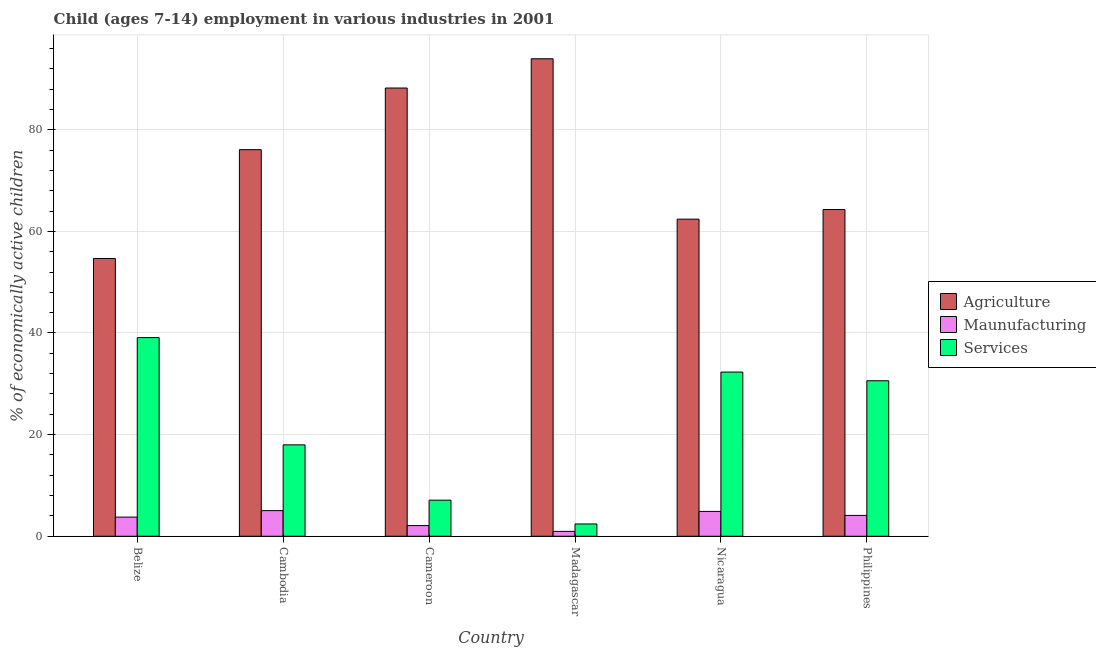How many groups of bars are there?
Provide a succinct answer. 6. Are the number of bars on each tick of the X-axis equal?
Provide a succinct answer. Yes. What is the label of the 5th group of bars from the left?
Offer a very short reply. Nicaragua. In how many cases, is the number of bars for a given country not equal to the number of legend labels?
Your response must be concise. 0. Across all countries, what is the maximum percentage of economically active children in manufacturing?
Your answer should be compact. 5.04. Across all countries, what is the minimum percentage of economically active children in manufacturing?
Make the answer very short. 0.96. In which country was the percentage of economically active children in agriculture maximum?
Provide a succinct answer. Madagascar. In which country was the percentage of economically active children in manufacturing minimum?
Your response must be concise. Madagascar. What is the total percentage of economically active children in agriculture in the graph?
Your answer should be compact. 439.63. What is the difference between the percentage of economically active children in services in Belize and that in Philippines?
Your response must be concise. 8.49. What is the difference between the percentage of economically active children in manufacturing in Cambodia and the percentage of economically active children in agriculture in Madagascar?
Ensure brevity in your answer.  -88.93. What is the average percentage of economically active children in agriculture per country?
Keep it short and to the point. 73.27. What is the difference between the percentage of economically active children in agriculture and percentage of economically active children in manufacturing in Madagascar?
Offer a terse response. 93.01. What is the ratio of the percentage of economically active children in manufacturing in Madagascar to that in Nicaragua?
Keep it short and to the point. 0.2. Is the difference between the percentage of economically active children in agriculture in Cambodia and Nicaragua greater than the difference between the percentage of economically active children in manufacturing in Cambodia and Nicaragua?
Offer a very short reply. Yes. What is the difference between the highest and the second highest percentage of economically active children in services?
Offer a terse response. 6.78. What is the difference between the highest and the lowest percentage of economically active children in manufacturing?
Give a very brief answer. 4.08. What does the 1st bar from the left in Nicaragua represents?
Ensure brevity in your answer.  Agriculture. What does the 2nd bar from the right in Madagascar represents?
Provide a succinct answer. Maunufacturing. Is it the case that in every country, the sum of the percentage of economically active children in agriculture and percentage of economically active children in manufacturing is greater than the percentage of economically active children in services?
Offer a terse response. Yes. Are all the bars in the graph horizontal?
Ensure brevity in your answer.  No. Are the values on the major ticks of Y-axis written in scientific E-notation?
Offer a very short reply. No. Does the graph contain any zero values?
Your answer should be compact. No. Where does the legend appear in the graph?
Your answer should be very brief. Center right. How many legend labels are there?
Offer a terse response. 3. What is the title of the graph?
Your answer should be very brief. Child (ages 7-14) employment in various industries in 2001. What is the label or title of the X-axis?
Make the answer very short. Country. What is the label or title of the Y-axis?
Keep it short and to the point. % of economically active children. What is the % of economically active children in Agriculture in Belize?
Offer a terse response. 54.66. What is the % of economically active children of Maunufacturing in Belize?
Your answer should be compact. 3.77. What is the % of economically active children of Services in Belize?
Offer a terse response. 39.09. What is the % of economically active children of Agriculture in Cambodia?
Make the answer very short. 76.08. What is the % of economically active children in Maunufacturing in Cambodia?
Ensure brevity in your answer.  5.04. What is the % of economically active children in Services in Cambodia?
Your response must be concise. 17.99. What is the % of economically active children in Agriculture in Cameroon?
Provide a succinct answer. 88.21. What is the % of economically active children of Maunufacturing in Cameroon?
Your answer should be very brief. 2.1. What is the % of economically active children of Services in Cameroon?
Provide a short and direct response. 7.1. What is the % of economically active children in Agriculture in Madagascar?
Offer a terse response. 93.97. What is the % of economically active children of Services in Madagascar?
Provide a short and direct response. 2.42. What is the % of economically active children in Agriculture in Nicaragua?
Keep it short and to the point. 62.41. What is the % of economically active children of Maunufacturing in Nicaragua?
Your response must be concise. 4.89. What is the % of economically active children in Services in Nicaragua?
Provide a succinct answer. 32.31. What is the % of economically active children of Agriculture in Philippines?
Your answer should be very brief. 64.3. What is the % of economically active children of Maunufacturing in Philippines?
Give a very brief answer. 4.1. What is the % of economically active children of Services in Philippines?
Ensure brevity in your answer.  30.6. Across all countries, what is the maximum % of economically active children in Agriculture?
Provide a short and direct response. 93.97. Across all countries, what is the maximum % of economically active children of Maunufacturing?
Make the answer very short. 5.04. Across all countries, what is the maximum % of economically active children in Services?
Your answer should be very brief. 39.09. Across all countries, what is the minimum % of economically active children of Agriculture?
Your answer should be very brief. 54.66. Across all countries, what is the minimum % of economically active children in Maunufacturing?
Provide a short and direct response. 0.96. Across all countries, what is the minimum % of economically active children of Services?
Your answer should be compact. 2.42. What is the total % of economically active children in Agriculture in the graph?
Keep it short and to the point. 439.63. What is the total % of economically active children of Maunufacturing in the graph?
Offer a terse response. 20.86. What is the total % of economically active children in Services in the graph?
Offer a very short reply. 129.52. What is the difference between the % of economically active children in Agriculture in Belize and that in Cambodia?
Offer a terse response. -21.42. What is the difference between the % of economically active children in Maunufacturing in Belize and that in Cambodia?
Make the answer very short. -1.27. What is the difference between the % of economically active children of Services in Belize and that in Cambodia?
Your response must be concise. 21.1. What is the difference between the % of economically active children of Agriculture in Belize and that in Cameroon?
Your response must be concise. -33.55. What is the difference between the % of economically active children of Maunufacturing in Belize and that in Cameroon?
Your answer should be compact. 1.67. What is the difference between the % of economically active children in Services in Belize and that in Cameroon?
Ensure brevity in your answer.  31.99. What is the difference between the % of economically active children of Agriculture in Belize and that in Madagascar?
Your answer should be compact. -39.31. What is the difference between the % of economically active children in Maunufacturing in Belize and that in Madagascar?
Provide a short and direct response. 2.81. What is the difference between the % of economically active children of Services in Belize and that in Madagascar?
Offer a terse response. 36.67. What is the difference between the % of economically active children of Agriculture in Belize and that in Nicaragua?
Offer a very short reply. -7.74. What is the difference between the % of economically active children of Maunufacturing in Belize and that in Nicaragua?
Keep it short and to the point. -1.12. What is the difference between the % of economically active children of Services in Belize and that in Nicaragua?
Provide a short and direct response. 6.78. What is the difference between the % of economically active children of Agriculture in Belize and that in Philippines?
Provide a succinct answer. -9.64. What is the difference between the % of economically active children in Maunufacturing in Belize and that in Philippines?
Offer a terse response. -0.33. What is the difference between the % of economically active children in Services in Belize and that in Philippines?
Provide a short and direct response. 8.49. What is the difference between the % of economically active children in Agriculture in Cambodia and that in Cameroon?
Make the answer very short. -12.13. What is the difference between the % of economically active children of Maunufacturing in Cambodia and that in Cameroon?
Your answer should be very brief. 2.94. What is the difference between the % of economically active children in Services in Cambodia and that in Cameroon?
Make the answer very short. 10.89. What is the difference between the % of economically active children of Agriculture in Cambodia and that in Madagascar?
Provide a succinct answer. -17.89. What is the difference between the % of economically active children in Maunufacturing in Cambodia and that in Madagascar?
Ensure brevity in your answer.  4.08. What is the difference between the % of economically active children in Services in Cambodia and that in Madagascar?
Provide a succinct answer. 15.57. What is the difference between the % of economically active children in Agriculture in Cambodia and that in Nicaragua?
Offer a very short reply. 13.67. What is the difference between the % of economically active children of Maunufacturing in Cambodia and that in Nicaragua?
Your answer should be compact. 0.15. What is the difference between the % of economically active children of Services in Cambodia and that in Nicaragua?
Your answer should be very brief. -14.32. What is the difference between the % of economically active children of Agriculture in Cambodia and that in Philippines?
Your answer should be very brief. 11.78. What is the difference between the % of economically active children of Maunufacturing in Cambodia and that in Philippines?
Your answer should be very brief. 0.94. What is the difference between the % of economically active children of Services in Cambodia and that in Philippines?
Ensure brevity in your answer.  -12.61. What is the difference between the % of economically active children in Agriculture in Cameroon and that in Madagascar?
Provide a succinct answer. -5.76. What is the difference between the % of economically active children in Maunufacturing in Cameroon and that in Madagascar?
Provide a short and direct response. 1.14. What is the difference between the % of economically active children in Services in Cameroon and that in Madagascar?
Provide a succinct answer. 4.68. What is the difference between the % of economically active children in Agriculture in Cameroon and that in Nicaragua?
Ensure brevity in your answer.  25.8. What is the difference between the % of economically active children in Maunufacturing in Cameroon and that in Nicaragua?
Your response must be concise. -2.79. What is the difference between the % of economically active children in Services in Cameroon and that in Nicaragua?
Provide a succinct answer. -25.21. What is the difference between the % of economically active children in Agriculture in Cameroon and that in Philippines?
Provide a short and direct response. 23.91. What is the difference between the % of economically active children in Services in Cameroon and that in Philippines?
Provide a short and direct response. -23.5. What is the difference between the % of economically active children of Agriculture in Madagascar and that in Nicaragua?
Give a very brief answer. 31.56. What is the difference between the % of economically active children of Maunufacturing in Madagascar and that in Nicaragua?
Make the answer very short. -3.93. What is the difference between the % of economically active children of Services in Madagascar and that in Nicaragua?
Make the answer very short. -29.89. What is the difference between the % of economically active children in Agriculture in Madagascar and that in Philippines?
Give a very brief answer. 29.67. What is the difference between the % of economically active children of Maunufacturing in Madagascar and that in Philippines?
Offer a very short reply. -3.14. What is the difference between the % of economically active children in Services in Madagascar and that in Philippines?
Offer a terse response. -28.18. What is the difference between the % of economically active children of Agriculture in Nicaragua and that in Philippines?
Offer a very short reply. -1.89. What is the difference between the % of economically active children in Maunufacturing in Nicaragua and that in Philippines?
Keep it short and to the point. 0.79. What is the difference between the % of economically active children of Services in Nicaragua and that in Philippines?
Your answer should be very brief. 1.71. What is the difference between the % of economically active children of Agriculture in Belize and the % of economically active children of Maunufacturing in Cambodia?
Make the answer very short. 49.62. What is the difference between the % of economically active children in Agriculture in Belize and the % of economically active children in Services in Cambodia?
Offer a very short reply. 36.67. What is the difference between the % of economically active children in Maunufacturing in Belize and the % of economically active children in Services in Cambodia?
Provide a short and direct response. -14.22. What is the difference between the % of economically active children in Agriculture in Belize and the % of economically active children in Maunufacturing in Cameroon?
Give a very brief answer. 52.56. What is the difference between the % of economically active children in Agriculture in Belize and the % of economically active children in Services in Cameroon?
Give a very brief answer. 47.56. What is the difference between the % of economically active children in Maunufacturing in Belize and the % of economically active children in Services in Cameroon?
Make the answer very short. -3.33. What is the difference between the % of economically active children of Agriculture in Belize and the % of economically active children of Maunufacturing in Madagascar?
Make the answer very short. 53.7. What is the difference between the % of economically active children of Agriculture in Belize and the % of economically active children of Services in Madagascar?
Offer a terse response. 52.24. What is the difference between the % of economically active children of Maunufacturing in Belize and the % of economically active children of Services in Madagascar?
Ensure brevity in your answer.  1.35. What is the difference between the % of economically active children in Agriculture in Belize and the % of economically active children in Maunufacturing in Nicaragua?
Your answer should be compact. 49.78. What is the difference between the % of economically active children of Agriculture in Belize and the % of economically active children of Services in Nicaragua?
Make the answer very short. 22.35. What is the difference between the % of economically active children in Maunufacturing in Belize and the % of economically active children in Services in Nicaragua?
Your answer should be compact. -28.54. What is the difference between the % of economically active children in Agriculture in Belize and the % of economically active children in Maunufacturing in Philippines?
Ensure brevity in your answer.  50.56. What is the difference between the % of economically active children in Agriculture in Belize and the % of economically active children in Services in Philippines?
Make the answer very short. 24.06. What is the difference between the % of economically active children in Maunufacturing in Belize and the % of economically active children in Services in Philippines?
Ensure brevity in your answer.  -26.83. What is the difference between the % of economically active children in Agriculture in Cambodia and the % of economically active children in Maunufacturing in Cameroon?
Offer a very short reply. 73.98. What is the difference between the % of economically active children of Agriculture in Cambodia and the % of economically active children of Services in Cameroon?
Offer a terse response. 68.98. What is the difference between the % of economically active children in Maunufacturing in Cambodia and the % of economically active children in Services in Cameroon?
Provide a succinct answer. -2.06. What is the difference between the % of economically active children of Agriculture in Cambodia and the % of economically active children of Maunufacturing in Madagascar?
Offer a terse response. 75.12. What is the difference between the % of economically active children in Agriculture in Cambodia and the % of economically active children in Services in Madagascar?
Ensure brevity in your answer.  73.66. What is the difference between the % of economically active children of Maunufacturing in Cambodia and the % of economically active children of Services in Madagascar?
Keep it short and to the point. 2.62. What is the difference between the % of economically active children in Agriculture in Cambodia and the % of economically active children in Maunufacturing in Nicaragua?
Provide a short and direct response. 71.19. What is the difference between the % of economically active children in Agriculture in Cambodia and the % of economically active children in Services in Nicaragua?
Ensure brevity in your answer.  43.77. What is the difference between the % of economically active children in Maunufacturing in Cambodia and the % of economically active children in Services in Nicaragua?
Provide a short and direct response. -27.27. What is the difference between the % of economically active children of Agriculture in Cambodia and the % of economically active children of Maunufacturing in Philippines?
Give a very brief answer. 71.98. What is the difference between the % of economically active children of Agriculture in Cambodia and the % of economically active children of Services in Philippines?
Offer a terse response. 45.48. What is the difference between the % of economically active children of Maunufacturing in Cambodia and the % of economically active children of Services in Philippines?
Your answer should be compact. -25.56. What is the difference between the % of economically active children in Agriculture in Cameroon and the % of economically active children in Maunufacturing in Madagascar?
Your answer should be compact. 87.25. What is the difference between the % of economically active children in Agriculture in Cameroon and the % of economically active children in Services in Madagascar?
Keep it short and to the point. 85.79. What is the difference between the % of economically active children in Maunufacturing in Cameroon and the % of economically active children in Services in Madagascar?
Ensure brevity in your answer.  -0.32. What is the difference between the % of economically active children in Agriculture in Cameroon and the % of economically active children in Maunufacturing in Nicaragua?
Offer a terse response. 83.32. What is the difference between the % of economically active children of Agriculture in Cameroon and the % of economically active children of Services in Nicaragua?
Offer a terse response. 55.9. What is the difference between the % of economically active children of Maunufacturing in Cameroon and the % of economically active children of Services in Nicaragua?
Provide a short and direct response. -30.21. What is the difference between the % of economically active children in Agriculture in Cameroon and the % of economically active children in Maunufacturing in Philippines?
Give a very brief answer. 84.11. What is the difference between the % of economically active children of Agriculture in Cameroon and the % of economically active children of Services in Philippines?
Your answer should be compact. 57.61. What is the difference between the % of economically active children of Maunufacturing in Cameroon and the % of economically active children of Services in Philippines?
Make the answer very short. -28.5. What is the difference between the % of economically active children in Agriculture in Madagascar and the % of economically active children in Maunufacturing in Nicaragua?
Make the answer very short. 89.08. What is the difference between the % of economically active children of Agriculture in Madagascar and the % of economically active children of Services in Nicaragua?
Your response must be concise. 61.66. What is the difference between the % of economically active children in Maunufacturing in Madagascar and the % of economically active children in Services in Nicaragua?
Your answer should be compact. -31.35. What is the difference between the % of economically active children of Agriculture in Madagascar and the % of economically active children of Maunufacturing in Philippines?
Keep it short and to the point. 89.87. What is the difference between the % of economically active children in Agriculture in Madagascar and the % of economically active children in Services in Philippines?
Give a very brief answer. 63.37. What is the difference between the % of economically active children of Maunufacturing in Madagascar and the % of economically active children of Services in Philippines?
Your answer should be very brief. -29.64. What is the difference between the % of economically active children of Agriculture in Nicaragua and the % of economically active children of Maunufacturing in Philippines?
Offer a very short reply. 58.31. What is the difference between the % of economically active children of Agriculture in Nicaragua and the % of economically active children of Services in Philippines?
Ensure brevity in your answer.  31.81. What is the difference between the % of economically active children in Maunufacturing in Nicaragua and the % of economically active children in Services in Philippines?
Provide a short and direct response. -25.71. What is the average % of economically active children in Agriculture per country?
Ensure brevity in your answer.  73.27. What is the average % of economically active children in Maunufacturing per country?
Offer a very short reply. 3.48. What is the average % of economically active children in Services per country?
Your answer should be very brief. 21.59. What is the difference between the % of economically active children in Agriculture and % of economically active children in Maunufacturing in Belize?
Provide a succinct answer. 50.9. What is the difference between the % of economically active children in Agriculture and % of economically active children in Services in Belize?
Provide a short and direct response. 15.57. What is the difference between the % of economically active children in Maunufacturing and % of economically active children in Services in Belize?
Keep it short and to the point. -35.33. What is the difference between the % of economically active children in Agriculture and % of economically active children in Maunufacturing in Cambodia?
Keep it short and to the point. 71.04. What is the difference between the % of economically active children in Agriculture and % of economically active children in Services in Cambodia?
Provide a succinct answer. 58.09. What is the difference between the % of economically active children in Maunufacturing and % of economically active children in Services in Cambodia?
Make the answer very short. -12.95. What is the difference between the % of economically active children of Agriculture and % of economically active children of Maunufacturing in Cameroon?
Make the answer very short. 86.11. What is the difference between the % of economically active children in Agriculture and % of economically active children in Services in Cameroon?
Provide a succinct answer. 81.11. What is the difference between the % of economically active children of Maunufacturing and % of economically active children of Services in Cameroon?
Offer a terse response. -5. What is the difference between the % of economically active children of Agriculture and % of economically active children of Maunufacturing in Madagascar?
Give a very brief answer. 93.01. What is the difference between the % of economically active children in Agriculture and % of economically active children in Services in Madagascar?
Provide a succinct answer. 91.55. What is the difference between the % of economically active children of Maunufacturing and % of economically active children of Services in Madagascar?
Provide a short and direct response. -1.46. What is the difference between the % of economically active children in Agriculture and % of economically active children in Maunufacturing in Nicaragua?
Offer a very short reply. 57.52. What is the difference between the % of economically active children of Agriculture and % of economically active children of Services in Nicaragua?
Your answer should be compact. 30.09. What is the difference between the % of economically active children in Maunufacturing and % of economically active children in Services in Nicaragua?
Your answer should be compact. -27.42. What is the difference between the % of economically active children of Agriculture and % of economically active children of Maunufacturing in Philippines?
Your answer should be compact. 60.2. What is the difference between the % of economically active children of Agriculture and % of economically active children of Services in Philippines?
Provide a succinct answer. 33.7. What is the difference between the % of economically active children in Maunufacturing and % of economically active children in Services in Philippines?
Give a very brief answer. -26.5. What is the ratio of the % of economically active children in Agriculture in Belize to that in Cambodia?
Ensure brevity in your answer.  0.72. What is the ratio of the % of economically active children in Maunufacturing in Belize to that in Cambodia?
Provide a short and direct response. 0.75. What is the ratio of the % of economically active children of Services in Belize to that in Cambodia?
Make the answer very short. 2.17. What is the ratio of the % of economically active children in Agriculture in Belize to that in Cameroon?
Your answer should be very brief. 0.62. What is the ratio of the % of economically active children of Maunufacturing in Belize to that in Cameroon?
Your answer should be compact. 1.79. What is the ratio of the % of economically active children of Services in Belize to that in Cameroon?
Ensure brevity in your answer.  5.51. What is the ratio of the % of economically active children of Agriculture in Belize to that in Madagascar?
Ensure brevity in your answer.  0.58. What is the ratio of the % of economically active children in Maunufacturing in Belize to that in Madagascar?
Your answer should be very brief. 3.92. What is the ratio of the % of economically active children of Services in Belize to that in Madagascar?
Make the answer very short. 16.15. What is the ratio of the % of economically active children of Agriculture in Belize to that in Nicaragua?
Ensure brevity in your answer.  0.88. What is the ratio of the % of economically active children of Maunufacturing in Belize to that in Nicaragua?
Ensure brevity in your answer.  0.77. What is the ratio of the % of economically active children of Services in Belize to that in Nicaragua?
Provide a short and direct response. 1.21. What is the ratio of the % of economically active children of Agriculture in Belize to that in Philippines?
Your answer should be compact. 0.85. What is the ratio of the % of economically active children in Maunufacturing in Belize to that in Philippines?
Offer a terse response. 0.92. What is the ratio of the % of economically active children in Services in Belize to that in Philippines?
Ensure brevity in your answer.  1.28. What is the ratio of the % of economically active children of Agriculture in Cambodia to that in Cameroon?
Ensure brevity in your answer.  0.86. What is the ratio of the % of economically active children of Services in Cambodia to that in Cameroon?
Your answer should be very brief. 2.53. What is the ratio of the % of economically active children of Agriculture in Cambodia to that in Madagascar?
Give a very brief answer. 0.81. What is the ratio of the % of economically active children of Maunufacturing in Cambodia to that in Madagascar?
Make the answer very short. 5.25. What is the ratio of the % of economically active children in Services in Cambodia to that in Madagascar?
Offer a terse response. 7.43. What is the ratio of the % of economically active children in Agriculture in Cambodia to that in Nicaragua?
Provide a succinct answer. 1.22. What is the ratio of the % of economically active children of Maunufacturing in Cambodia to that in Nicaragua?
Give a very brief answer. 1.03. What is the ratio of the % of economically active children of Services in Cambodia to that in Nicaragua?
Offer a terse response. 0.56. What is the ratio of the % of economically active children in Agriculture in Cambodia to that in Philippines?
Make the answer very short. 1.18. What is the ratio of the % of economically active children of Maunufacturing in Cambodia to that in Philippines?
Provide a succinct answer. 1.23. What is the ratio of the % of economically active children in Services in Cambodia to that in Philippines?
Your answer should be compact. 0.59. What is the ratio of the % of economically active children of Agriculture in Cameroon to that in Madagascar?
Make the answer very short. 0.94. What is the ratio of the % of economically active children of Maunufacturing in Cameroon to that in Madagascar?
Offer a very short reply. 2.19. What is the ratio of the % of economically active children of Services in Cameroon to that in Madagascar?
Make the answer very short. 2.93. What is the ratio of the % of economically active children in Agriculture in Cameroon to that in Nicaragua?
Offer a very short reply. 1.41. What is the ratio of the % of economically active children of Maunufacturing in Cameroon to that in Nicaragua?
Offer a terse response. 0.43. What is the ratio of the % of economically active children of Services in Cameroon to that in Nicaragua?
Make the answer very short. 0.22. What is the ratio of the % of economically active children of Agriculture in Cameroon to that in Philippines?
Your response must be concise. 1.37. What is the ratio of the % of economically active children in Maunufacturing in Cameroon to that in Philippines?
Offer a terse response. 0.51. What is the ratio of the % of economically active children in Services in Cameroon to that in Philippines?
Ensure brevity in your answer.  0.23. What is the ratio of the % of economically active children in Agriculture in Madagascar to that in Nicaragua?
Keep it short and to the point. 1.51. What is the ratio of the % of economically active children in Maunufacturing in Madagascar to that in Nicaragua?
Provide a short and direct response. 0.2. What is the ratio of the % of economically active children of Services in Madagascar to that in Nicaragua?
Offer a very short reply. 0.07. What is the ratio of the % of economically active children in Agriculture in Madagascar to that in Philippines?
Make the answer very short. 1.46. What is the ratio of the % of economically active children in Maunufacturing in Madagascar to that in Philippines?
Your answer should be compact. 0.23. What is the ratio of the % of economically active children in Services in Madagascar to that in Philippines?
Offer a very short reply. 0.08. What is the ratio of the % of economically active children of Agriculture in Nicaragua to that in Philippines?
Ensure brevity in your answer.  0.97. What is the ratio of the % of economically active children of Maunufacturing in Nicaragua to that in Philippines?
Give a very brief answer. 1.19. What is the ratio of the % of economically active children in Services in Nicaragua to that in Philippines?
Your answer should be very brief. 1.06. What is the difference between the highest and the second highest % of economically active children of Agriculture?
Offer a very short reply. 5.76. What is the difference between the highest and the second highest % of economically active children in Maunufacturing?
Your answer should be very brief. 0.15. What is the difference between the highest and the second highest % of economically active children of Services?
Give a very brief answer. 6.78. What is the difference between the highest and the lowest % of economically active children of Agriculture?
Your answer should be compact. 39.31. What is the difference between the highest and the lowest % of economically active children in Maunufacturing?
Provide a succinct answer. 4.08. What is the difference between the highest and the lowest % of economically active children in Services?
Your response must be concise. 36.67. 